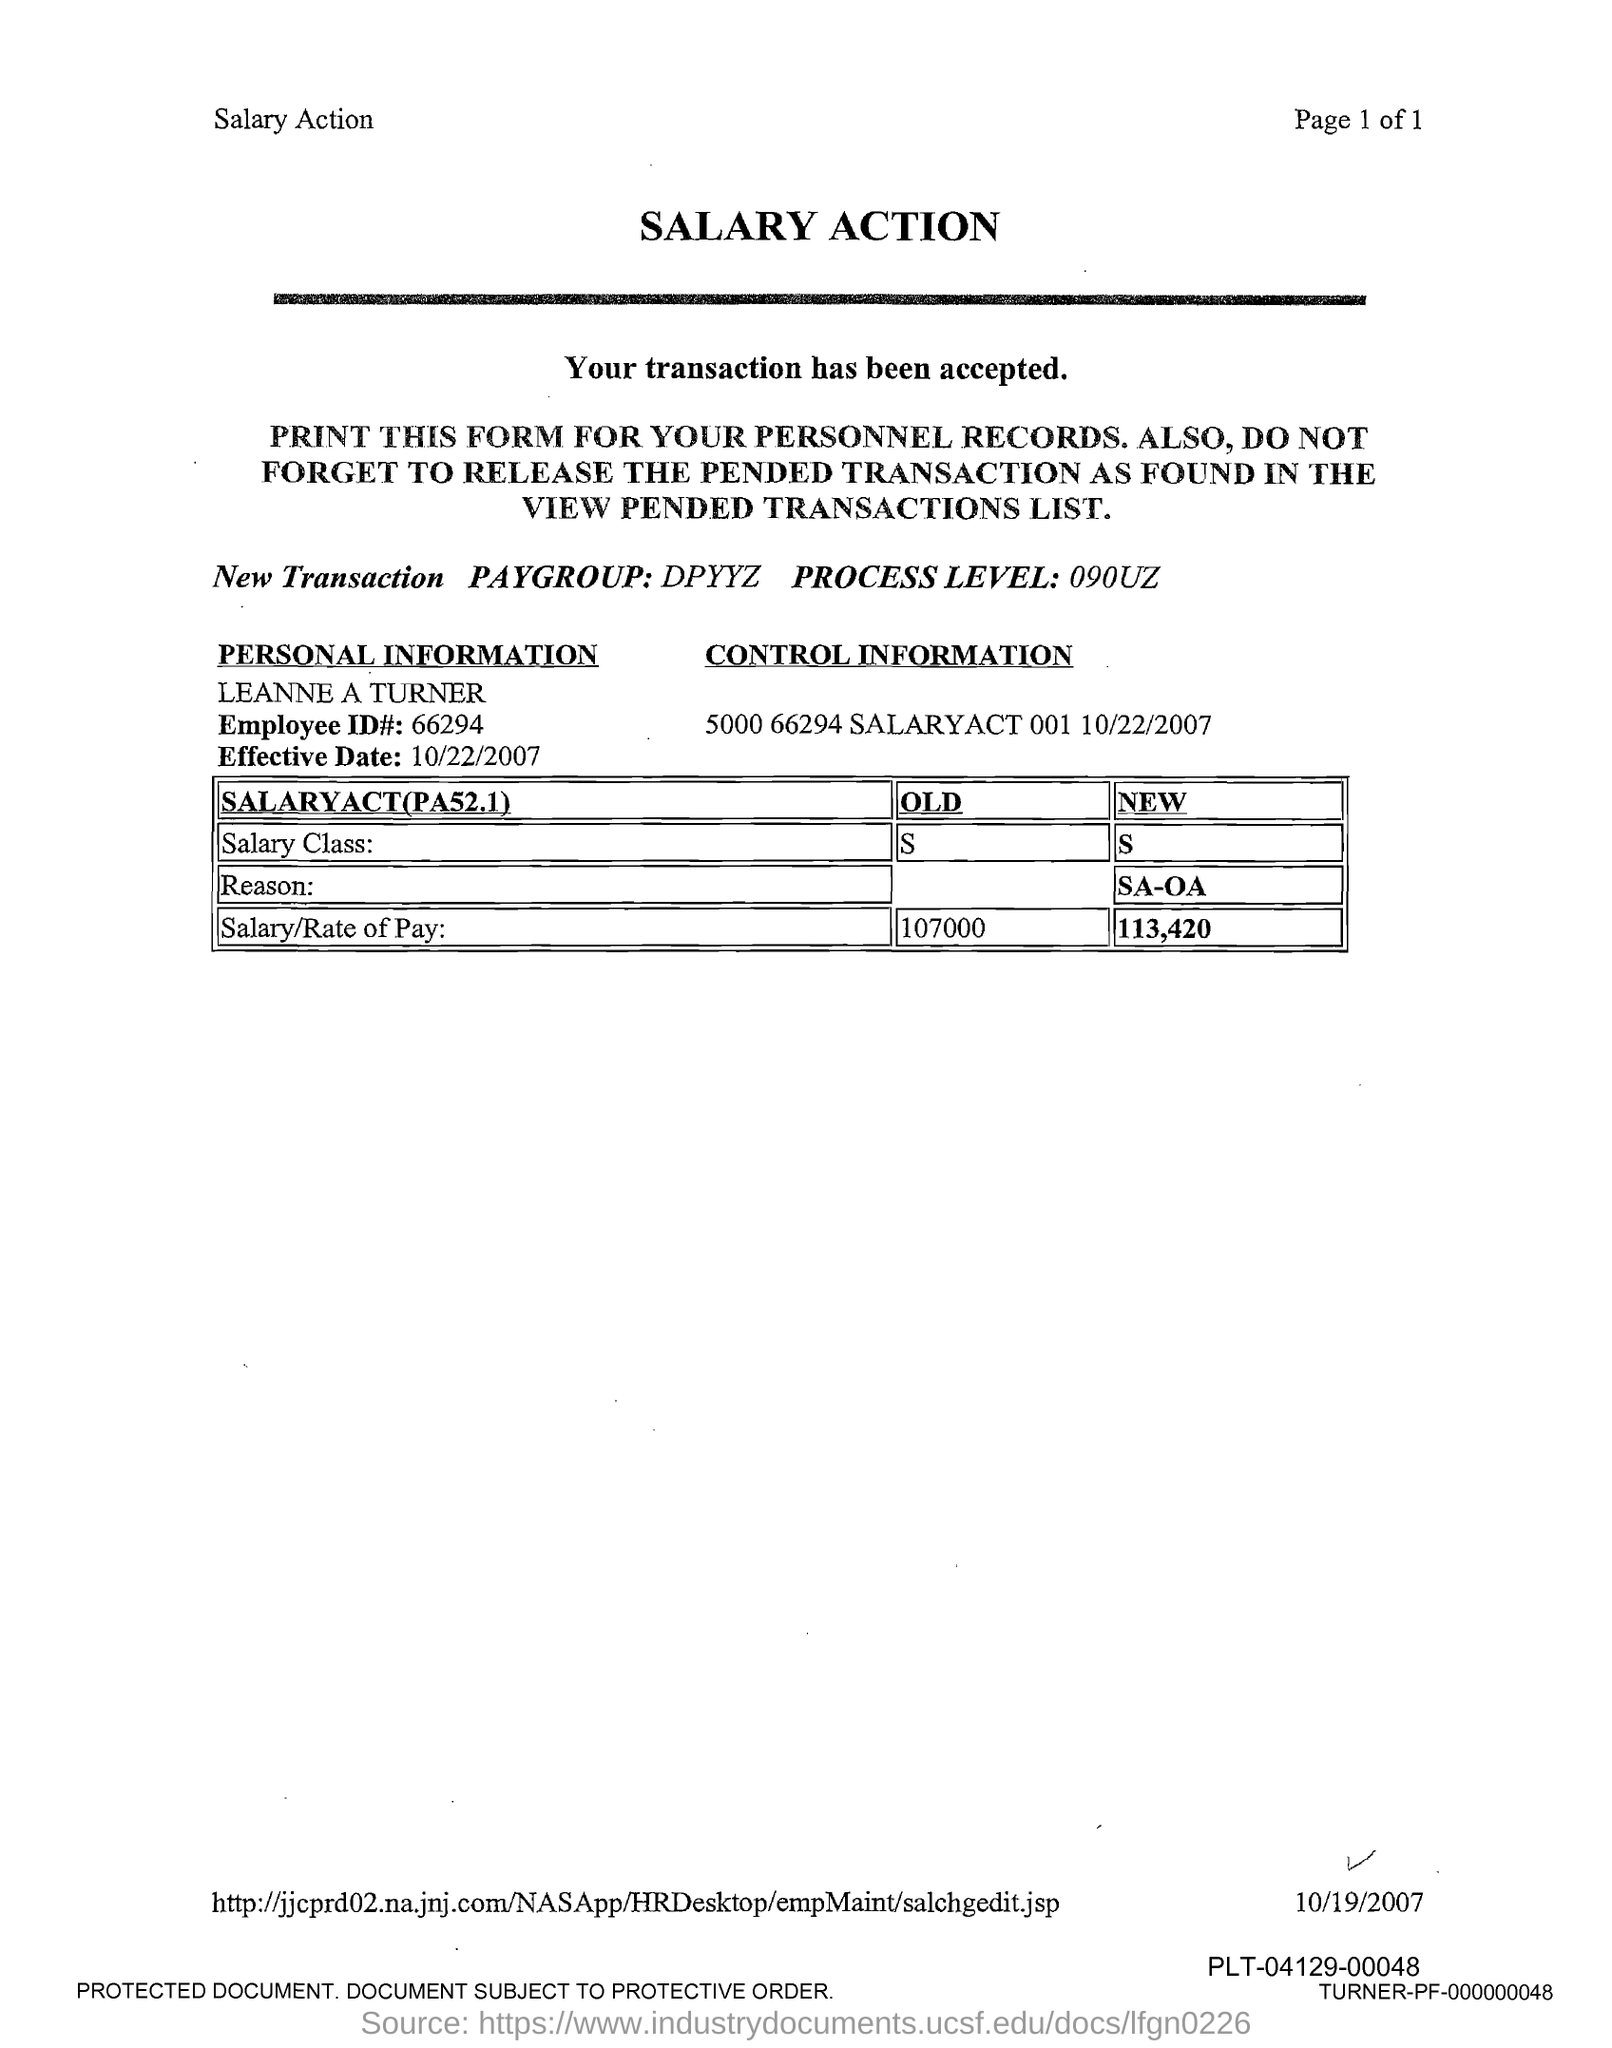What is the employee name given in theform?
Give a very brief answer. LEANNE A TURNER. What is the Employee ID# mentioned in the form?
Offer a very short reply. 66294. What is the Effective Date mentioned in this form?
Provide a succinct answer. 10/22/2007. What is the new salary class given in the form?
Give a very brief answer. S. What is the new salary/rate of pay of Leanne A Turner?
Keep it short and to the point. 113,420. What is the old salary/rate of pay of Leanne A Turner?
Your answer should be very brief. 107000. What is the title of this document?
Offer a terse response. SALARY ACTION. 